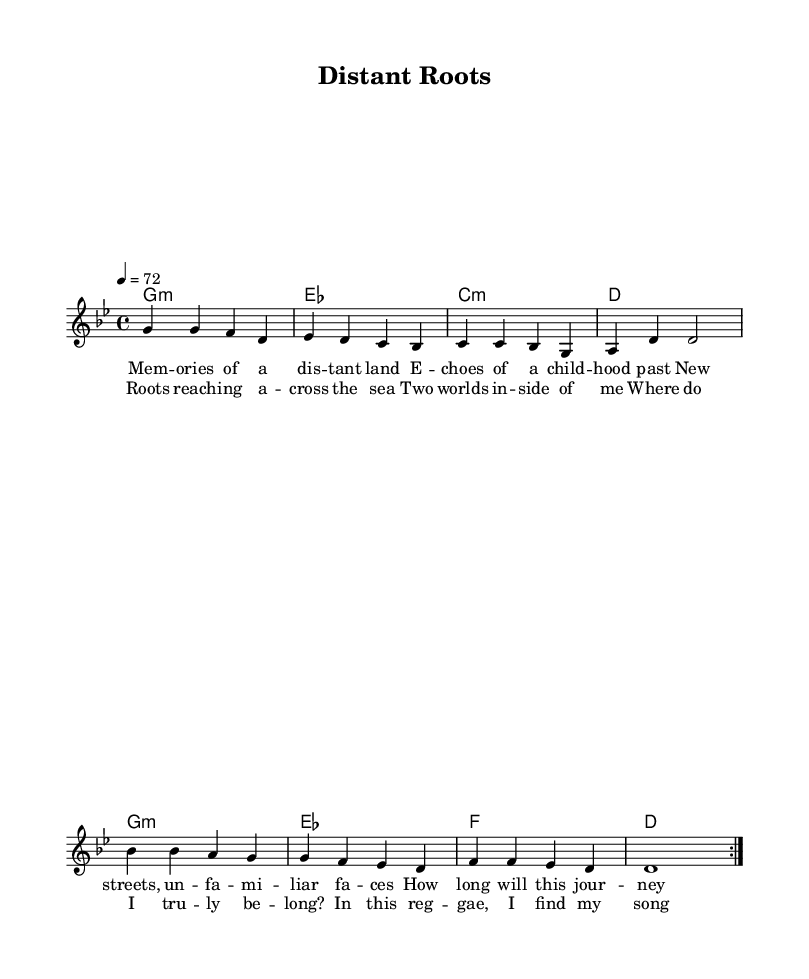What is the key signature of this music? The key signature indicates the key of G minor, which includes two flats: B flat and E flat. This can be identified in the beginning of the staff where the flats are placed.
Answer: G minor What is the time signature of this piece? The time signature shown at the beginning of the staff is 4/4. This is displayed as two stacked numbers, with a '4' on the top and a '4' on the bottom.
Answer: 4/4 What is the tempo marking for this piece? The tempo marking is indicated as 4 equals 72, which means the quarter note should be played at a pace of 72 beats per minute. This can be found right below the title in the score section.
Answer: 72 How many times is the melody repeated in the first section? The melody is marked with a repeat sign, which shows that the section should be played twice. The repeat signs are indicated at the beginning and end of the relevant measures.
Answer: 2 What are the primary themes explored in the lyrics? The lyrics discuss themes of displacement and cultural identity, which is clear from the verses that express longing for a distant place and the struggle of feeling apart from one’s roots. This can be inferred by reading the text provided under the melody line.
Answer: Displacement and cultural identity What is the main focus of the chorus section? The chorus emphasizes a connection between two worlds, highlighting the search for belonging. This is evident from the phrases in the chorus lyrics that mention 'two worlds inside of me' and 'where do I truly belong?'
Answer: Connection and belonging What type of musical genre does this piece represent? The structure and lyrical content clearly align with the roots reggae genre, particularly with its themes of cultural identity and social issues. This can be concluded through the stylistic elements apparent in the composition and lyrics.
Answer: Roots reggae 